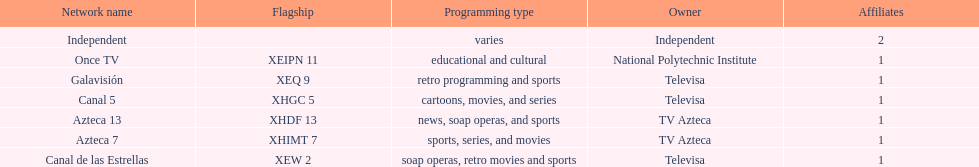What is the difference between the number of affiliates galavision has and the number of affiliates azteca 13 has? 0. 